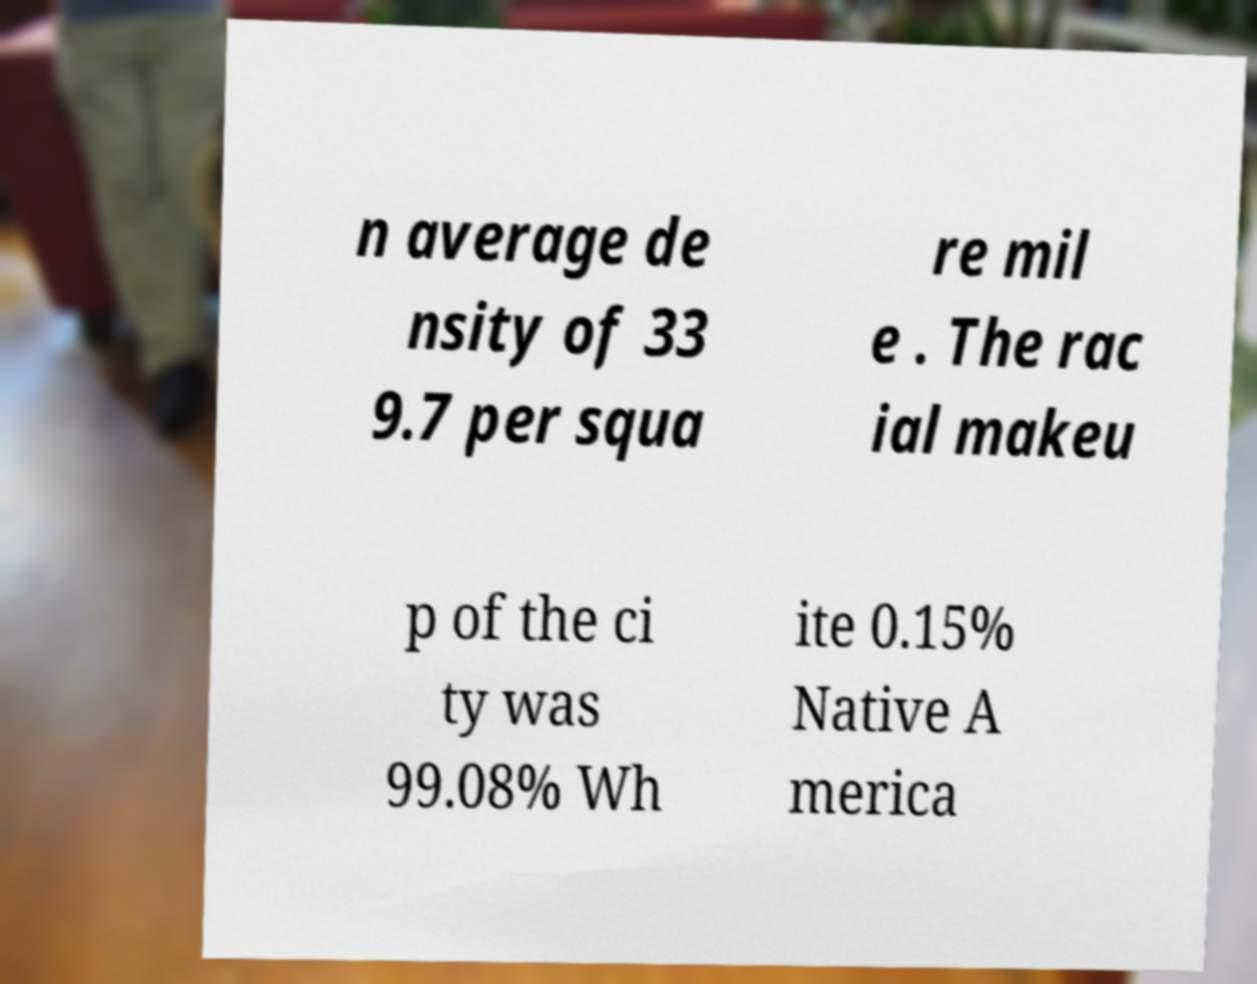Could you assist in decoding the text presented in this image and type it out clearly? n average de nsity of 33 9.7 per squa re mil e . The rac ial makeu p of the ci ty was 99.08% Wh ite 0.15% Native A merica 